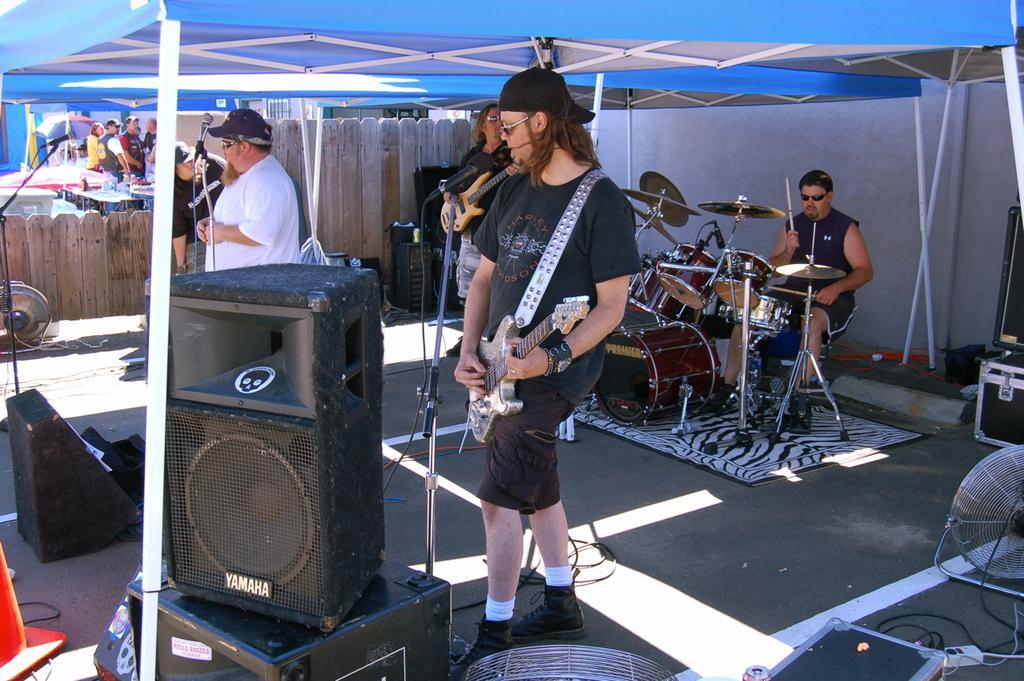Could you give a brief overview of what you see in this image? In this image there are group of people standing under the tent. There is a person in the front and playing guitar and at the back there is an another person standing and playing guitar. At the right the side there is a person sitting and playing drums. The person standing at the left is singing. At the right there are boxes and fan and at the front there are speakers. At the back there is a wooden fence. 